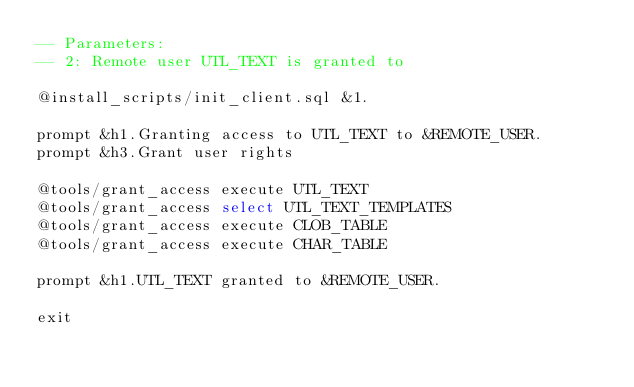Convert code to text. <code><loc_0><loc_0><loc_500><loc_500><_SQL_>-- Parameters:
-- 2: Remote user UTL_TEXT is granted to

@install_scripts/init_client.sql &1.

prompt &h1.Granting access to UTL_TEXT to &REMOTE_USER.
prompt &h3.Grant user rights

@tools/grant_access execute UTL_TEXT
@tools/grant_access select UTL_TEXT_TEMPLATES
@tools/grant_access execute CLOB_TABLE
@tools/grant_access execute CHAR_TABLE

prompt &h1.UTL_TEXT granted to &REMOTE_USER.

exit
</code> 